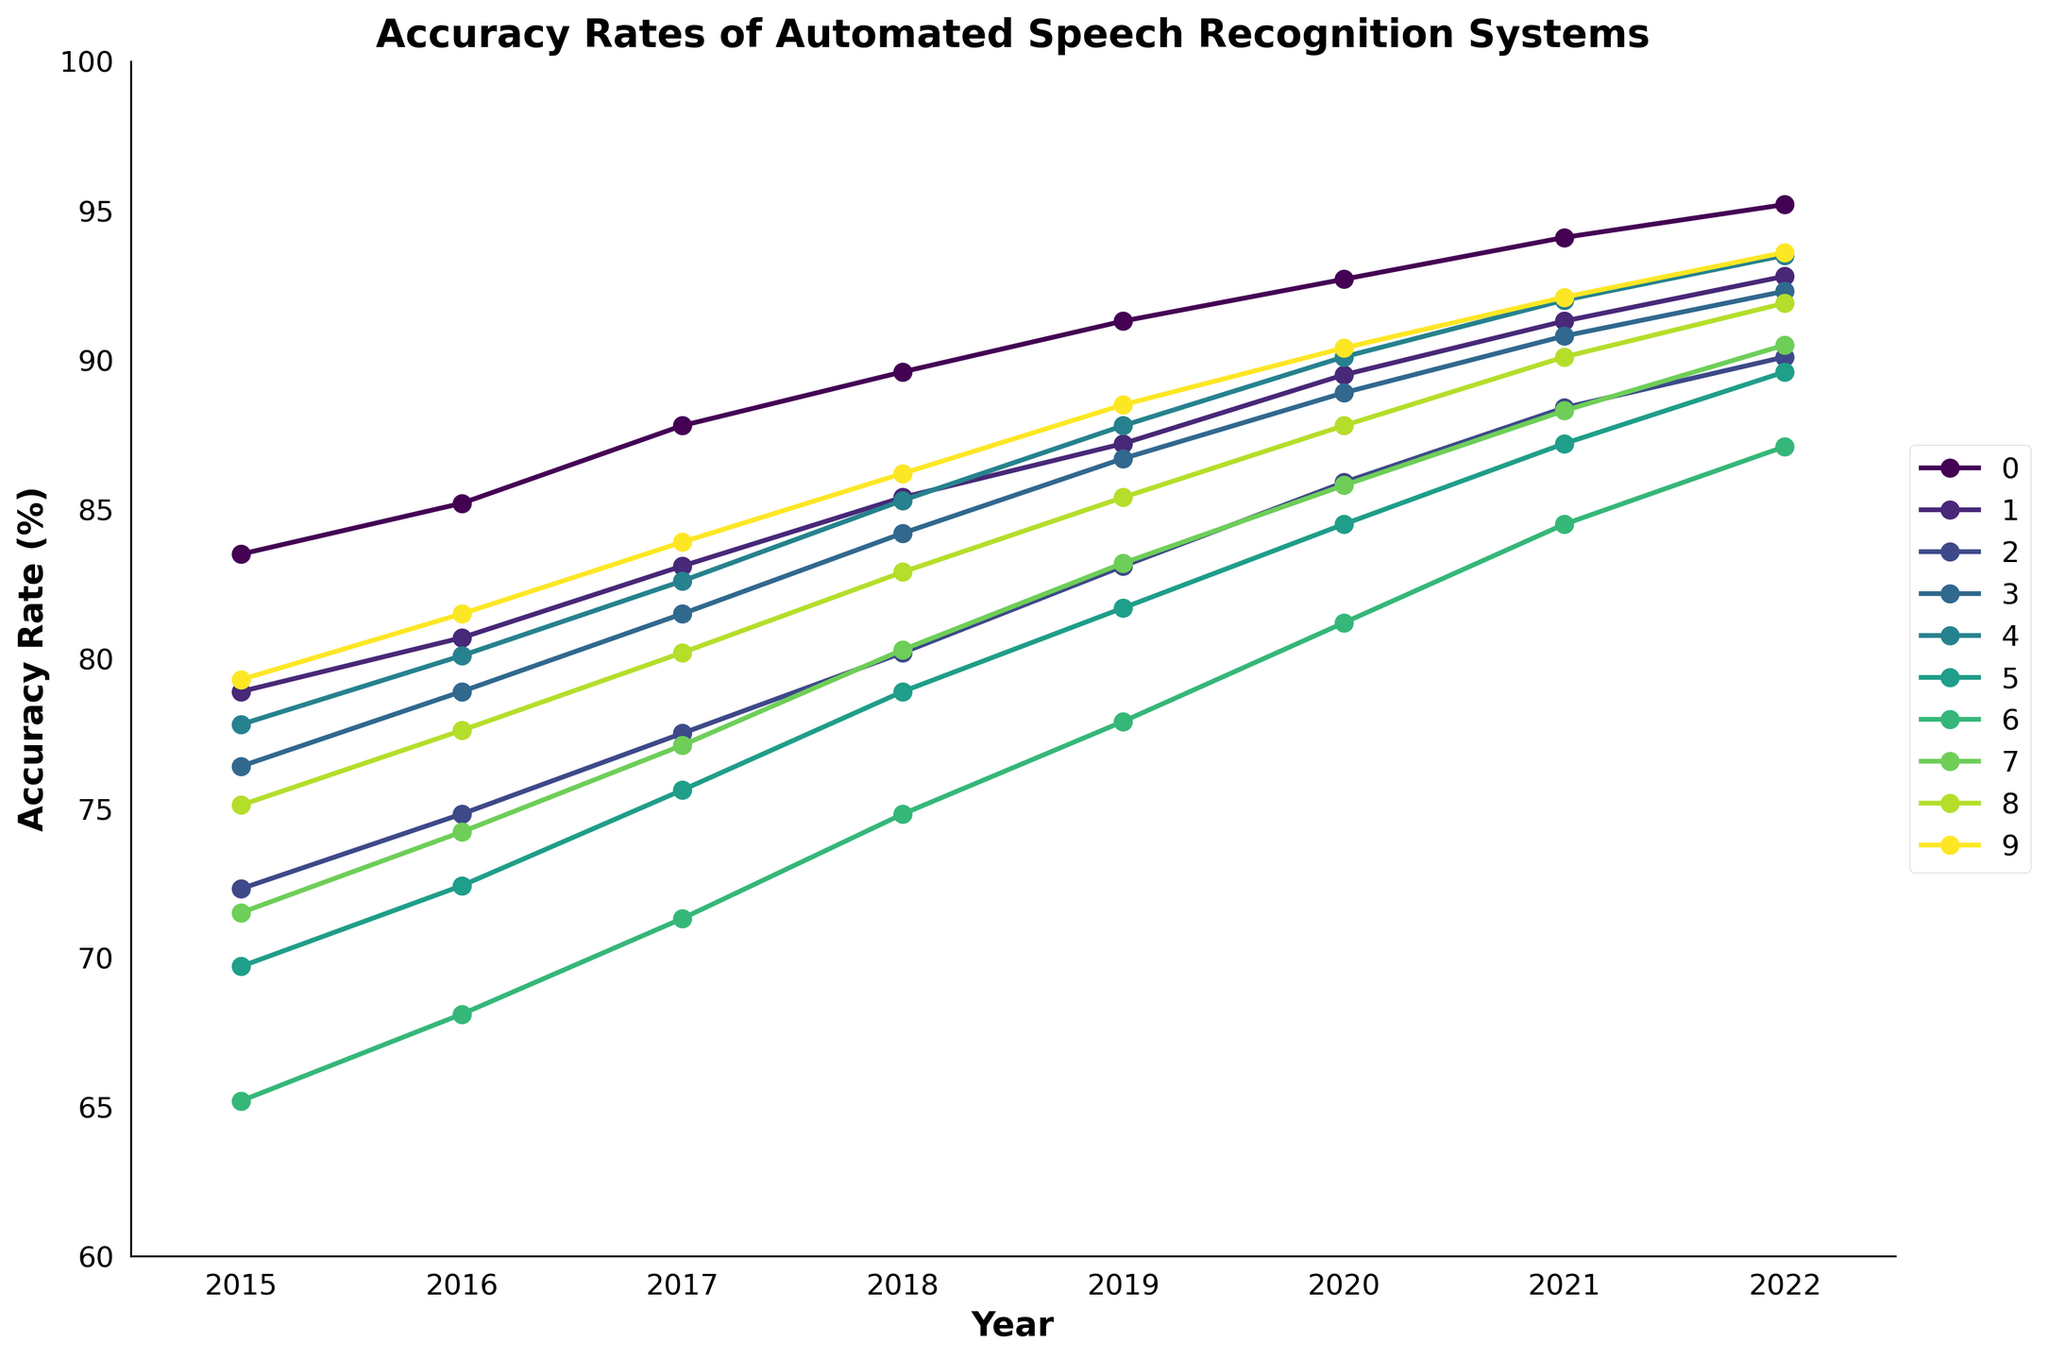Which language showed the highest accuracy rate in 2022? Look at the data points for each language in the year 2022 and find the highest value. The highest accuracy rate is 95.2 for English.
Answer: English Which language had the steepest improvement in accuracy rate from 2015 to 2022? Calculate the difference in accuracy rate between 2015 and 2022 for each language and find the largest difference. English improved by 11.7%, Spanish by 13.9%, Mandarin by 17.8%, French by 15.9%, German by 15.7%, Japanese by 19.9%, Arabic by 21.9%, Russian by 19.0%, Portuguese by 16.8%, and Italian by 14.3%. Arabic had the steepest improvement.
Answer: Arabic Compare the trend of accuracy rates for Spanish and Japanese between 2015 and 2022. Which language showed a more consistent upward trend? Observe the plot lines for both Spanish and Japanese. Spanish shows a consistent upward trend with minor fluctuations, while the Japanese line also shows a steady rise with more variability in improvements. Spanish has a more consistent upward trend.
Answer: Spanish What's the average accuracy rate for French in the years provided? Sum all accuracy rates for French (76.4, 78.9, 81.5, 84.2, 86.7, 88.9, 90.8, 92.3) and divide by the number of years (8). The total sum is 679.7, and the average is 679.7 / 8 = 84.96.
Answer: 84.96 Which two languages had an equal accuracy rate in any given year? Compare the yearly data points for all languages and find any equal values. In 2021, both Italian and German had an accuracy rate of 92.1.
Answer: Italian and German in 2021 How much did the accuracy rate for Mandarin increase from 2017 to 2018? Subtract the accuracy rate of Mandarin in 2017 from the rate in 2018. 80.2 - 77.5 = 2.7.
Answer: 2.7 Between 2015 and 2021, which language had the least improvement in accuracy rate? Calculate the difference from 2015 to 2021 for each language. English improved by 10.6%, Spanish by 12.4%, Mandarin by 16.1%, French by 14.4%, German by 14.2%, Japanese by 17.5%, Arabic by 19.3%, Russian by 16.8%, Portuguese by 15.0%, Italian by 12.8%. English had the least improvement with 10.6%.
Answer: English Is there a year where all languages improved their accuracy rate compared to the previous year? Look at each year and see if the accuracy rates for all languages were higher than the previous year. Every year shows improvement for all languages compared to the previous year.
Answer: Every year Which language showed the smallest accuracy rate increase from 2020 to 2021? Subtract the accuracy rates of each language in 2020 from those in 2021 and find the smallest difference. English increased by 1.4%, Spanish by 1.8%, Mandarin by 2.5%, French by 1.9%, German by 1.9%, Japanese by 2.7%, Arabic by 3.3%, Russian by 2.5%, Portuguese by 2.3%, Italian by 1.7%. English showed the smallest increase with 1.4%.
Answer: English Compare the visual line for Arabic to Russian from 2015 to 2022. Which had a higher average accuracy rate over these years? Calculate the average for both languages. Arabic: (65.2 + 68.1 + 71.3 + 74.8 + 77.9 + 81.2 + 84.5 + 87.1)/8 = 76.38. Russian: (71.5 + 74.2 + 77.1 + 80.3 + 83.2 + 85.8 + 88.3 + 90.5)/8 = 81.13. Russian has a higher average accuracy rate.
Answer: Russian 